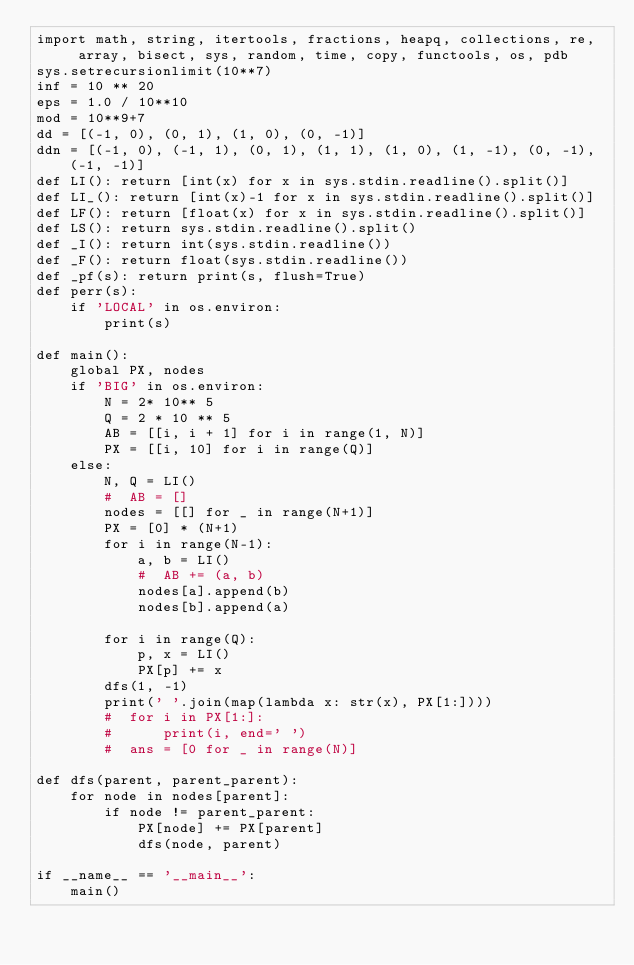Convert code to text. <code><loc_0><loc_0><loc_500><loc_500><_Python_>import math, string, itertools, fractions, heapq, collections, re,  array, bisect, sys, random, time, copy, functools, os, pdb
sys.setrecursionlimit(10**7)
inf = 10 ** 20
eps = 1.0 / 10**10
mod = 10**9+7
dd = [(-1, 0), (0, 1), (1, 0), (0, -1)]
ddn = [(-1, 0), (-1, 1), (0, 1), (1, 1), (1, 0), (1, -1), (0, -1), (-1, -1)]
def LI(): return [int(x) for x in sys.stdin.readline().split()]
def LI_(): return [int(x)-1 for x in sys.stdin.readline().split()]
def LF(): return [float(x) for x in sys.stdin.readline().split()]
def LS(): return sys.stdin.readline().split()
def _I(): return int(sys.stdin.readline())
def _F(): return float(sys.stdin.readline())
def _pf(s): return print(s, flush=True)
def perr(s):
    if 'LOCAL' in os.environ:
        print(s)

def main():
    global PX, nodes
    if 'BIG' in os.environ:
        N = 2* 10** 5
        Q = 2 * 10 ** 5
        AB = [[i, i + 1] for i in range(1, N)]
        PX = [[i, 10] for i in range(Q)]
    else:
        N, Q = LI()
        #  AB = []
        nodes = [[] for _ in range(N+1)]
        PX = [0] * (N+1)
        for i in range(N-1):
            a, b = LI()
            #  AB += (a, b)
            nodes[a].append(b)
            nodes[b].append(a)

        for i in range(Q):
            p, x = LI()
            PX[p] += x
        dfs(1, -1)
        print(' '.join(map(lambda x: str(x), PX[1:])))
        #  for i in PX[1:]:
        #      print(i, end=' ')
        #  ans = [0 for _ in range(N)]

def dfs(parent, parent_parent):
    for node in nodes[parent]:
        if node != parent_parent:
            PX[node] += PX[parent]
            dfs(node, parent)

if __name__ == '__main__':
    main()
</code> 